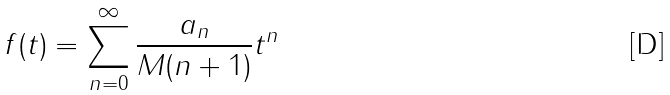Convert formula to latex. <formula><loc_0><loc_0><loc_500><loc_500>f ( t ) = \sum _ { n = 0 } ^ { \infty } { \frac { a _ { n } } { M ( n + 1 ) } } t ^ { n }</formula> 